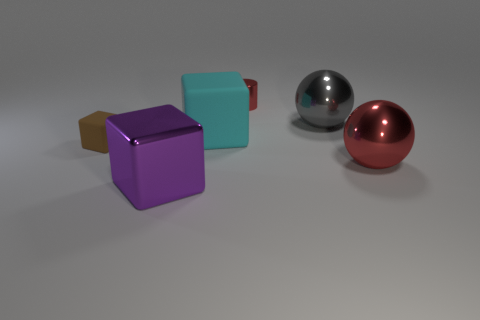How do the different textures of the objects contrast with each other? The contrasting textures are demonstrated by the varying way surfaces interact with light - the matte finish of the rubbery cubes diffuses light, the metal sphere reflects sharply with clear highlights, and the plastic-like sphere has a soft sheen, suggesting semi-translucency or a less reflective material. 